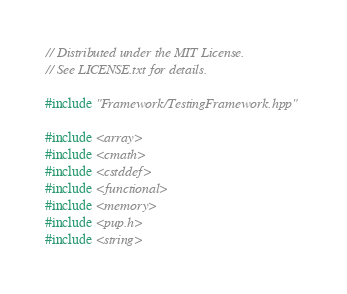Convert code to text. <code><loc_0><loc_0><loc_500><loc_500><_C++_>// Distributed under the MIT License.
// See LICENSE.txt for details.

#include "Framework/TestingFramework.hpp"

#include <array>
#include <cmath>
#include <cstddef>
#include <functional>
#include <memory>
#include <pup.h>
#include <string></code> 